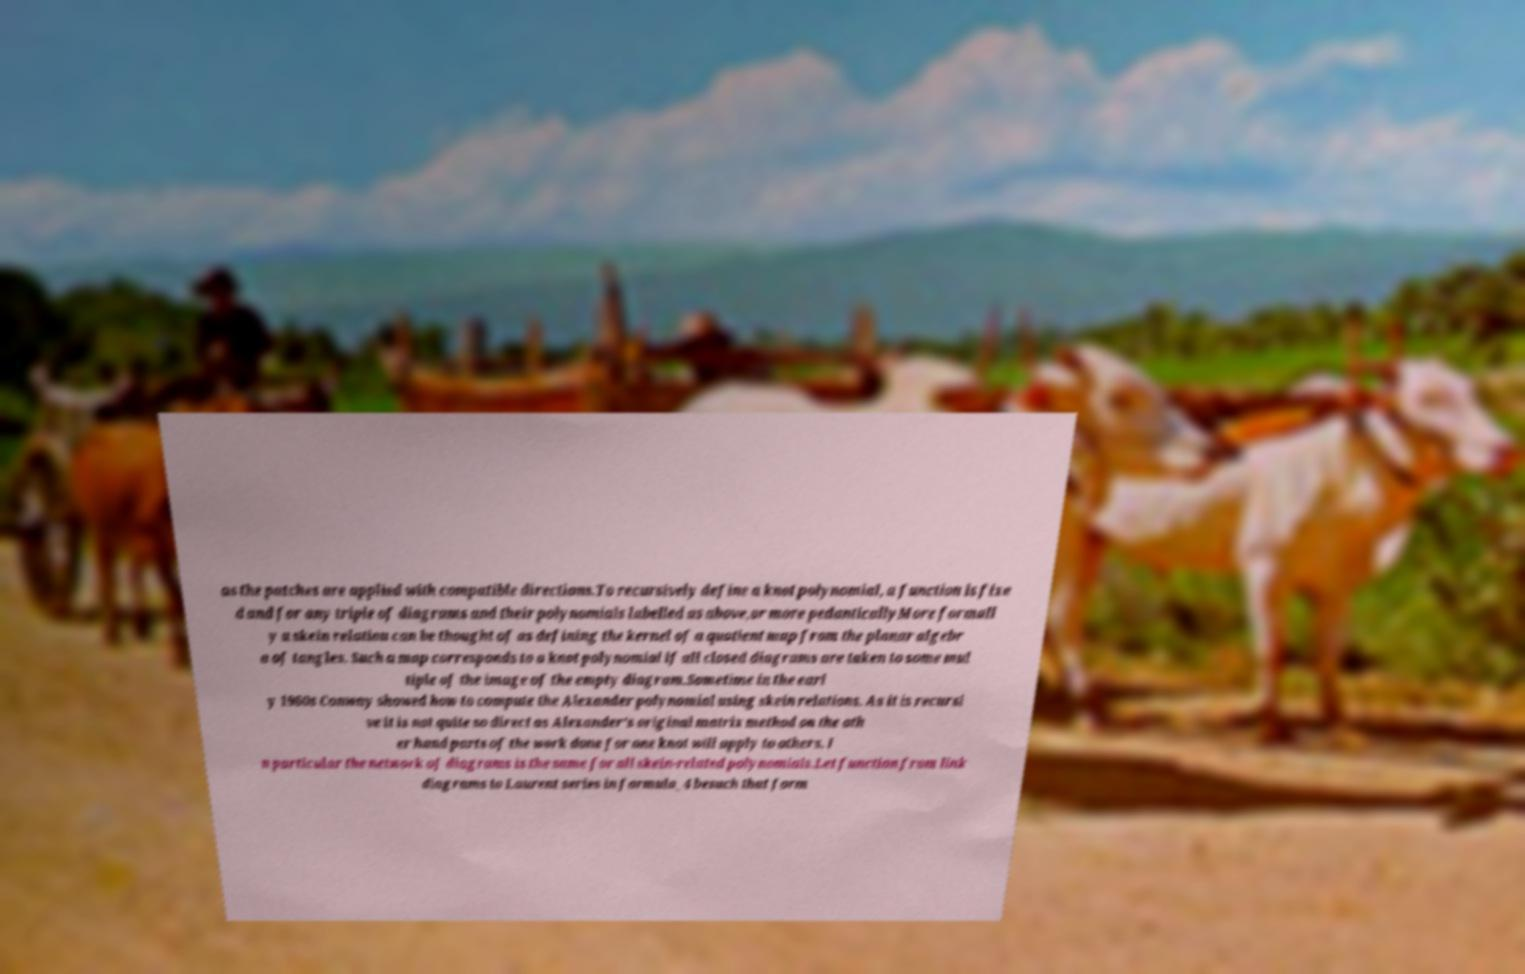Could you assist in decoding the text presented in this image and type it out clearly? as the patches are applied with compatible directions.To recursively define a knot polynomial, a function is fixe d and for any triple of diagrams and their polynomials labelled as above,or more pedanticallyMore formall y a skein relation can be thought of as defining the kernel of a quotient map from the planar algebr a of tangles. Such a map corresponds to a knot polynomial if all closed diagrams are taken to some mul tiple of the image of the empty diagram.Sometime in the earl y 1960s Conway showed how to compute the Alexander polynomial using skein relations. As it is recursi ve it is not quite so direct as Alexander's original matrix method on the oth er hand parts of the work done for one knot will apply to others. I n particular the network of diagrams is the same for all skein-related polynomials.Let function from link diagrams to Laurent series in formula_4 besuch that form 